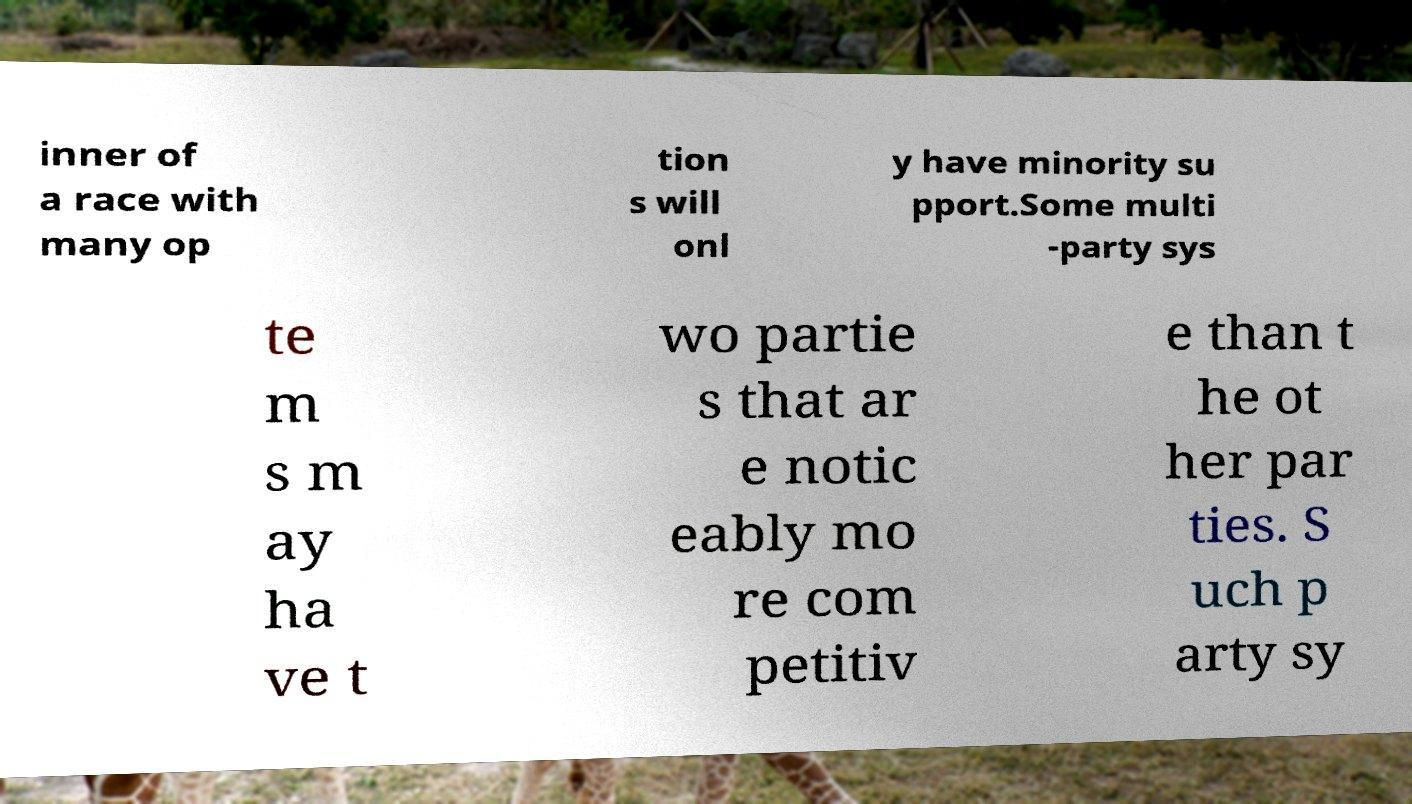Can you accurately transcribe the text from the provided image for me? inner of a race with many op tion s will onl y have minority su pport.Some multi -party sys te m s m ay ha ve t wo partie s that ar e notic eably mo re com petitiv e than t he ot her par ties. S uch p arty sy 